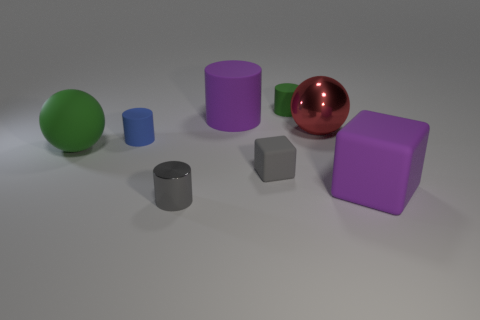Subtract all tiny green cylinders. How many cylinders are left? 3 Add 2 brown rubber things. How many objects exist? 10 Subtract all blue cylinders. How many cylinders are left? 3 Subtract 2 cylinders. How many cylinders are left? 2 Subtract all tiny yellow rubber objects. Subtract all big red spheres. How many objects are left? 7 Add 5 large spheres. How many large spheres are left? 7 Add 7 metallic balls. How many metallic balls exist? 8 Subtract 0 yellow balls. How many objects are left? 8 Subtract all cubes. How many objects are left? 6 Subtract all cyan cylinders. Subtract all red spheres. How many cylinders are left? 4 